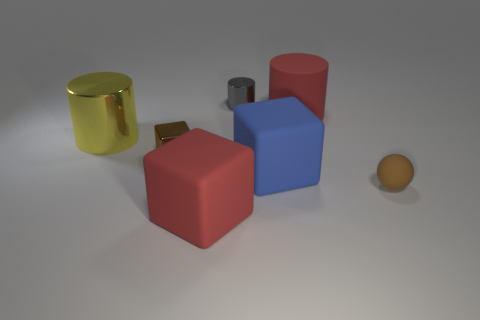Add 1 big red balls. How many objects exist? 8 Subtract all balls. How many objects are left? 6 Subtract 0 cyan spheres. How many objects are left? 7 Subtract all small cyan matte things. Subtract all large cubes. How many objects are left? 5 Add 5 gray objects. How many gray objects are left? 6 Add 7 big yellow objects. How many big yellow objects exist? 8 